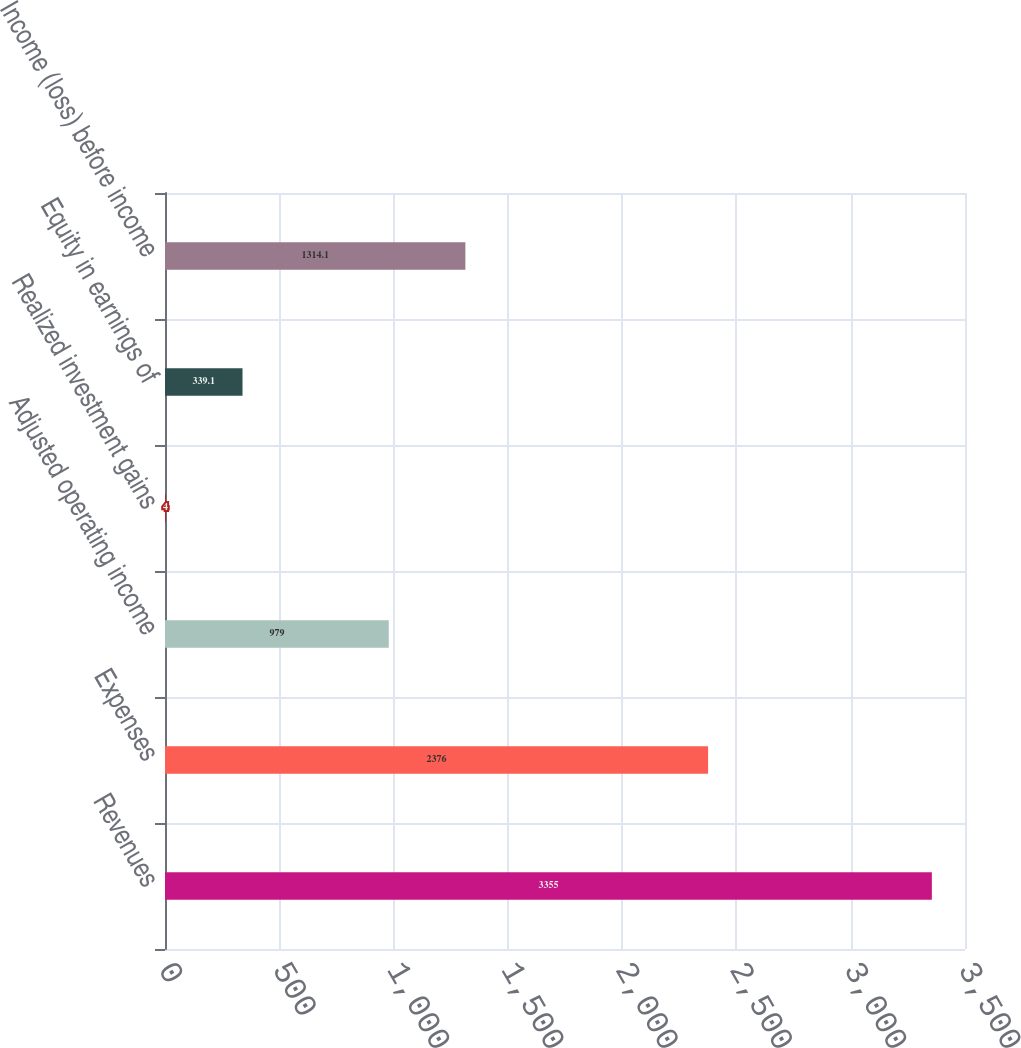Convert chart to OTSL. <chart><loc_0><loc_0><loc_500><loc_500><bar_chart><fcel>Revenues<fcel>Expenses<fcel>Adjusted operating income<fcel>Realized investment gains<fcel>Equity in earnings of<fcel>Income (loss) before income<nl><fcel>3355<fcel>2376<fcel>979<fcel>4<fcel>339.1<fcel>1314.1<nl></chart> 